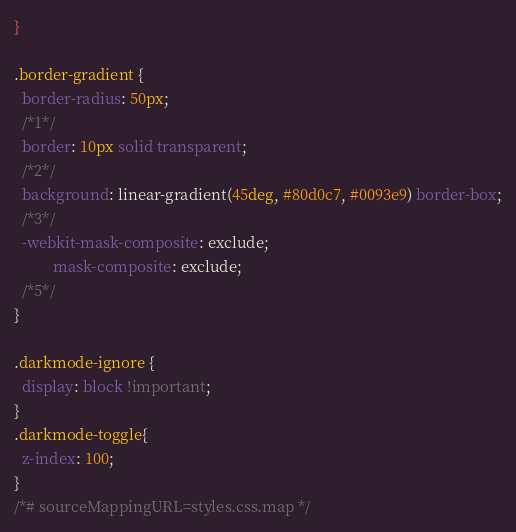<code> <loc_0><loc_0><loc_500><loc_500><_CSS_>}

.border-gradient {
  border-radius: 50px;
  /*1*/
  border: 10px solid transparent;
  /*2*/
  background: linear-gradient(45deg, #80d0c7, #0093e9) border-box;
  /*3*/
  -webkit-mask-composite: exclude;
          mask-composite: exclude;
  /*5*/
}

.darkmode-ignore {
  display: block !important;
}
.darkmode-toggle{
  z-index: 100;
}
/*# sourceMappingURL=styles.css.map */</code> 